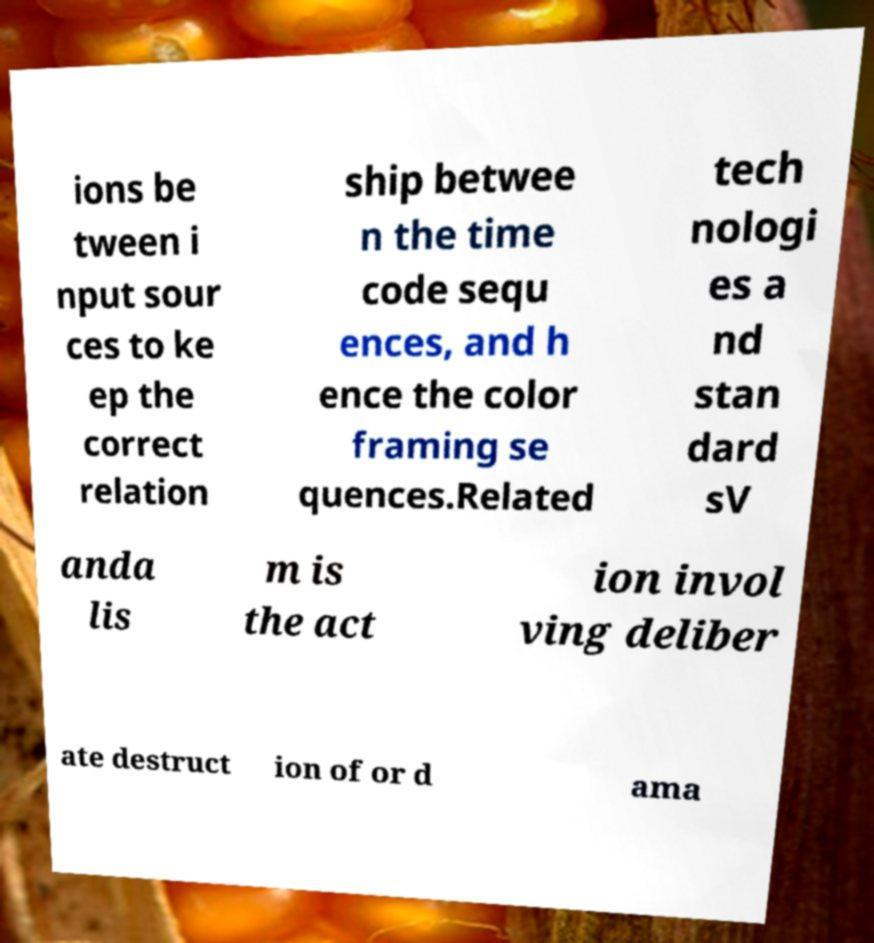Please identify and transcribe the text found in this image. ions be tween i nput sour ces to ke ep the correct relation ship betwee n the time code sequ ences, and h ence the color framing se quences.Related tech nologi es a nd stan dard sV anda lis m is the act ion invol ving deliber ate destruct ion of or d ama 